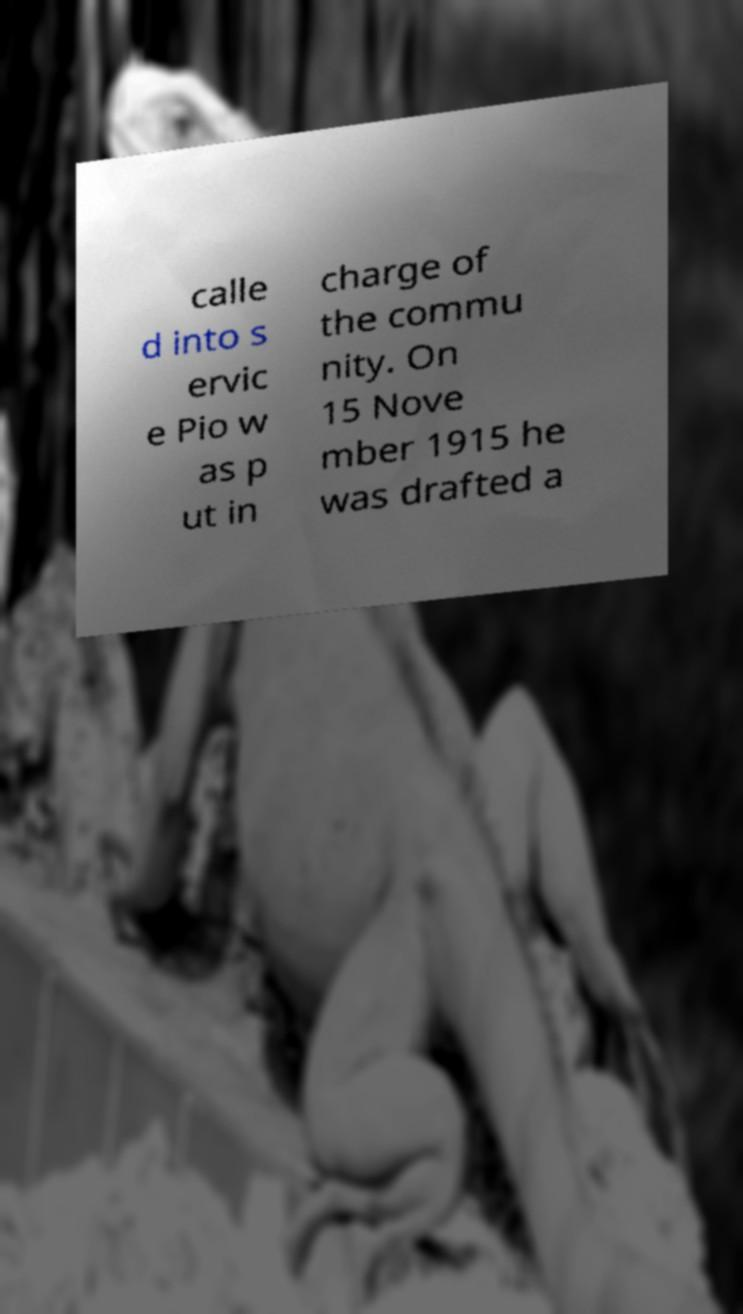Please identify and transcribe the text found in this image. calle d into s ervic e Pio w as p ut in charge of the commu nity. On 15 Nove mber 1915 he was drafted a 